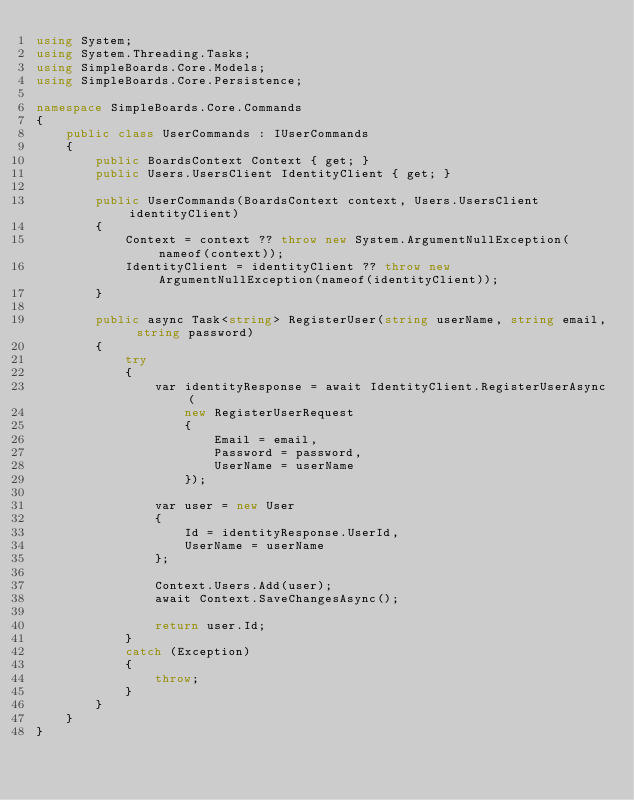Convert code to text. <code><loc_0><loc_0><loc_500><loc_500><_C#_>using System;
using System.Threading.Tasks;
using SimpleBoards.Core.Models;
using SimpleBoards.Core.Persistence;

namespace SimpleBoards.Core.Commands
{
    public class UserCommands : IUserCommands
    {
        public BoardsContext Context { get; }
        public Users.UsersClient IdentityClient { get; }

        public UserCommands(BoardsContext context, Users.UsersClient identityClient)
        {
            Context = context ?? throw new System.ArgumentNullException(nameof(context));
            IdentityClient = identityClient ?? throw new ArgumentNullException(nameof(identityClient));
        }

        public async Task<string> RegisterUser(string userName, string email, string password)
        {
            try
            {
                var identityResponse = await IdentityClient.RegisterUserAsync(
                    new RegisterUserRequest
                    {
                        Email = email,
                        Password = password,
                        UserName = userName
                    });

                var user = new User
                {
                    Id = identityResponse.UserId,
                    UserName = userName
                };

                Context.Users.Add(user);
                await Context.SaveChangesAsync();

                return user.Id;
            }
            catch (Exception)
            {
                throw;
            }
        }
    }
}</code> 